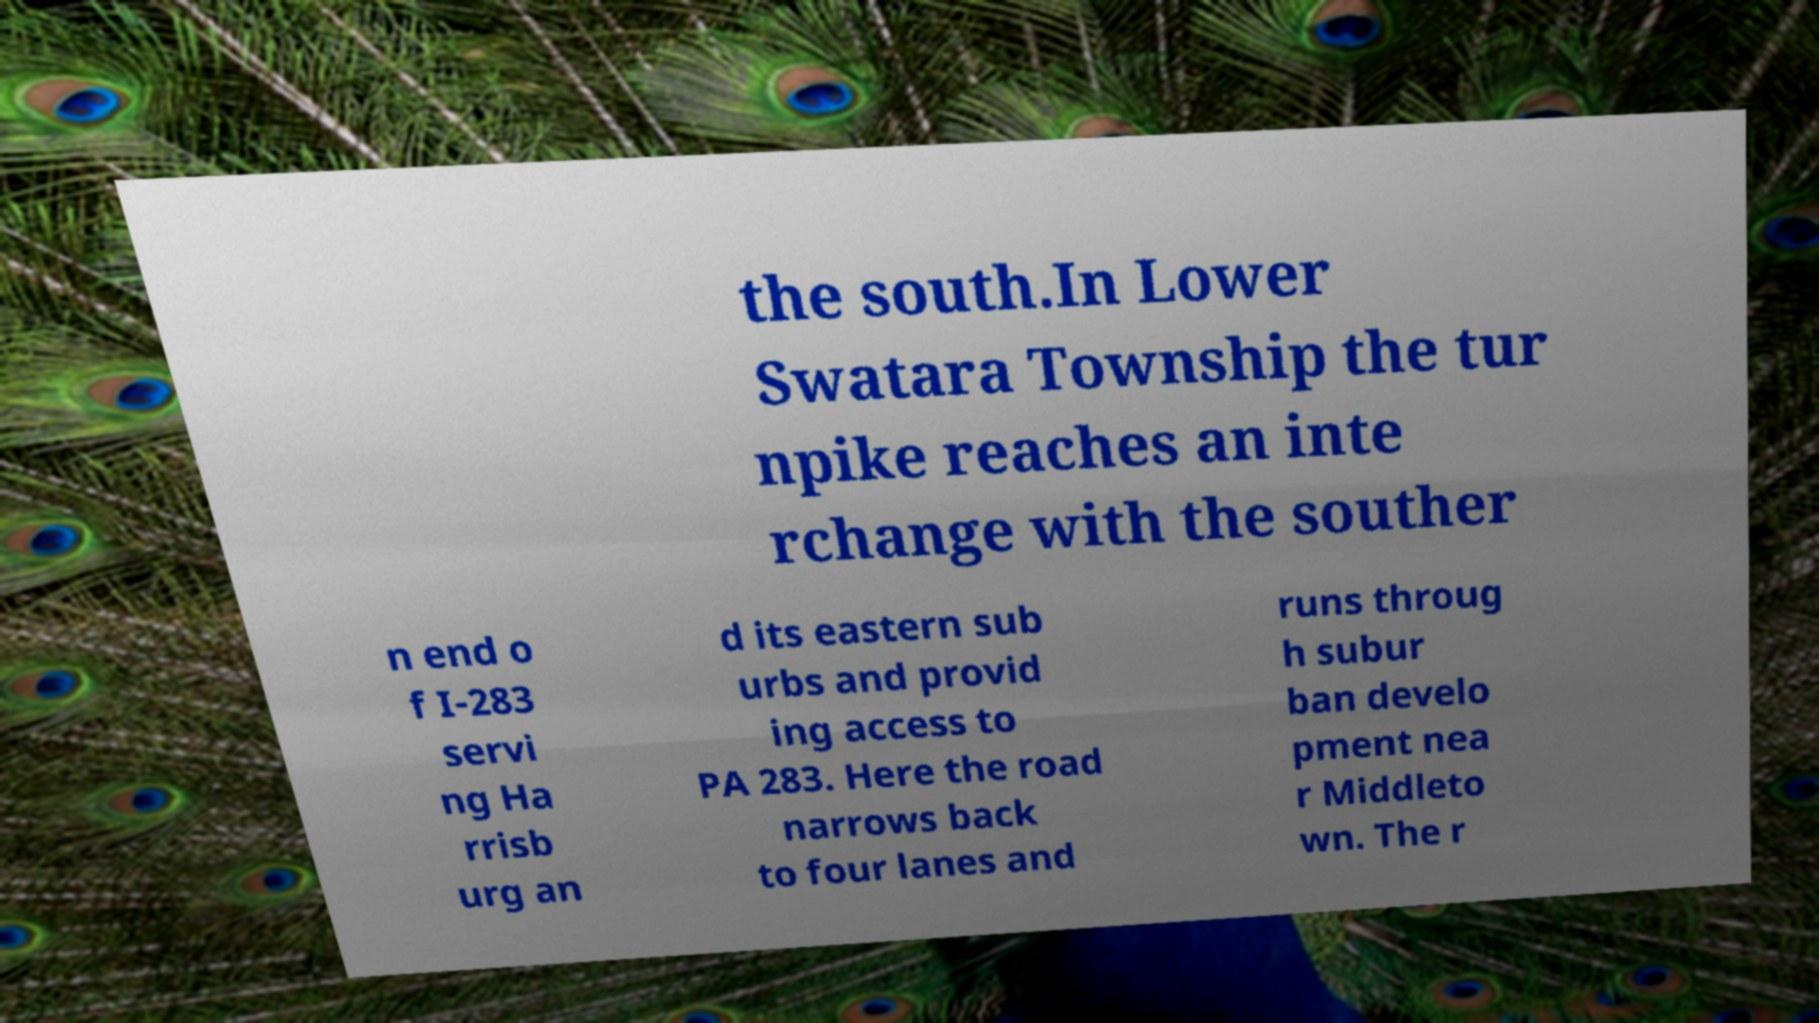What messages or text are displayed in this image? I need them in a readable, typed format. the south.In Lower Swatara Township the tur npike reaches an inte rchange with the souther n end o f I-283 servi ng Ha rrisb urg an d its eastern sub urbs and provid ing access to PA 283. Here the road narrows back to four lanes and runs throug h subur ban develo pment nea r Middleto wn. The r 